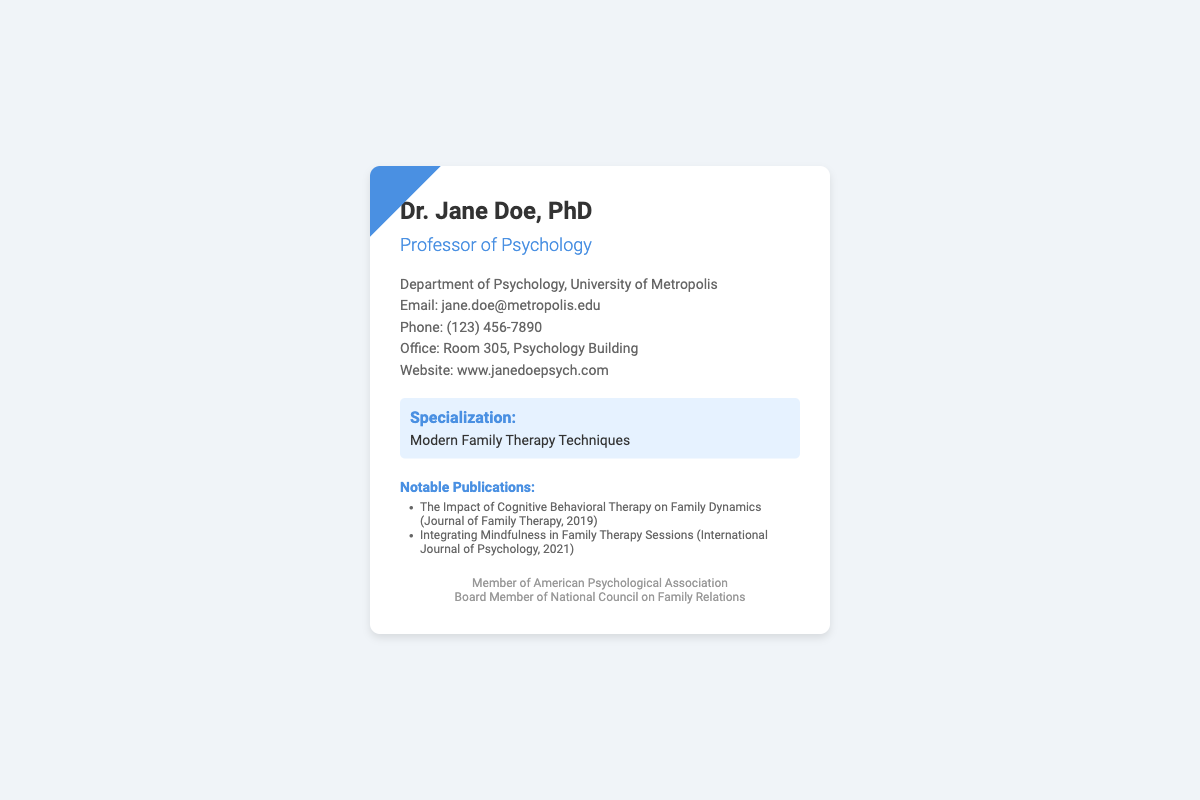What is Dr. Jane Doe's title? Dr. Jane Doe's title is provided in the heading of the card, stating her position in academia.
Answer: Professor of Psychology What is Dr. Jane Doe's email address? The email address is listed in the contact information section of the document.
Answer: jane.doe@metropolis.edu Which university does Dr. Jane Doe work for? The university name is mentioned in the contact details of the card.
Answer: University of Metropolis What is Dr. Jane Doe's area of specialization? The area of specialization is highlighted in a dedicated section on the card.
Answer: Modern Family Therapy Techniques How many notable publications are listed? The number of notable publications is determined by counting the items in the publications section.
Answer: 2 In which year was "The Impact of Cognitive Behavioral Therapy on Family Dynamics" published? The publication year is provided in the citation for this notable publication.
Answer: 2019 What is Dr. Jane Doe's office room number? The office room number is provided in the contact information section.
Answer: Room 305 Which professional organization is Dr. Jane Doe a member of? The membership information is found in the footer of the card.
Answer: American Psychological Association What is the phone number listed on the card? The phone number is included in the contact details section of the document.
Answer: (123) 456-7890 